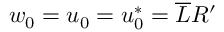<formula> <loc_0><loc_0><loc_500><loc_500>w _ { 0 } = u _ { 0 } = u _ { 0 } ^ { * } = \overline { L } R ^ { \prime }</formula> 